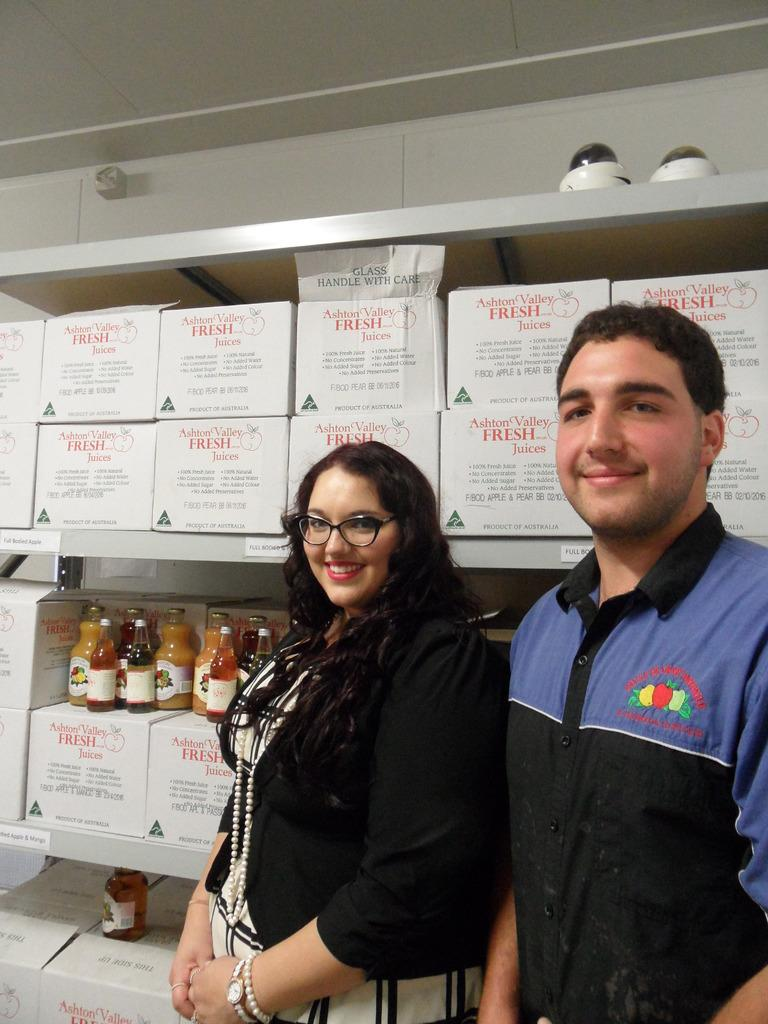How many people are in the image? There are two people in the image, a man and a woman. What are the man and the woman doing in the image? Both the man and the woman are standing and smiling. What can be seen in the background of the image? There are boxes and bottles on racks in the background. What is visible at the top of the image? The ceiling is visible at the top of the image. What type of stick is the woman holding in the image? There is no stick present in the image; the woman is not holding anything. Who is the aunt in the image? There is no mention of an aunt in the image or the provided facts. 